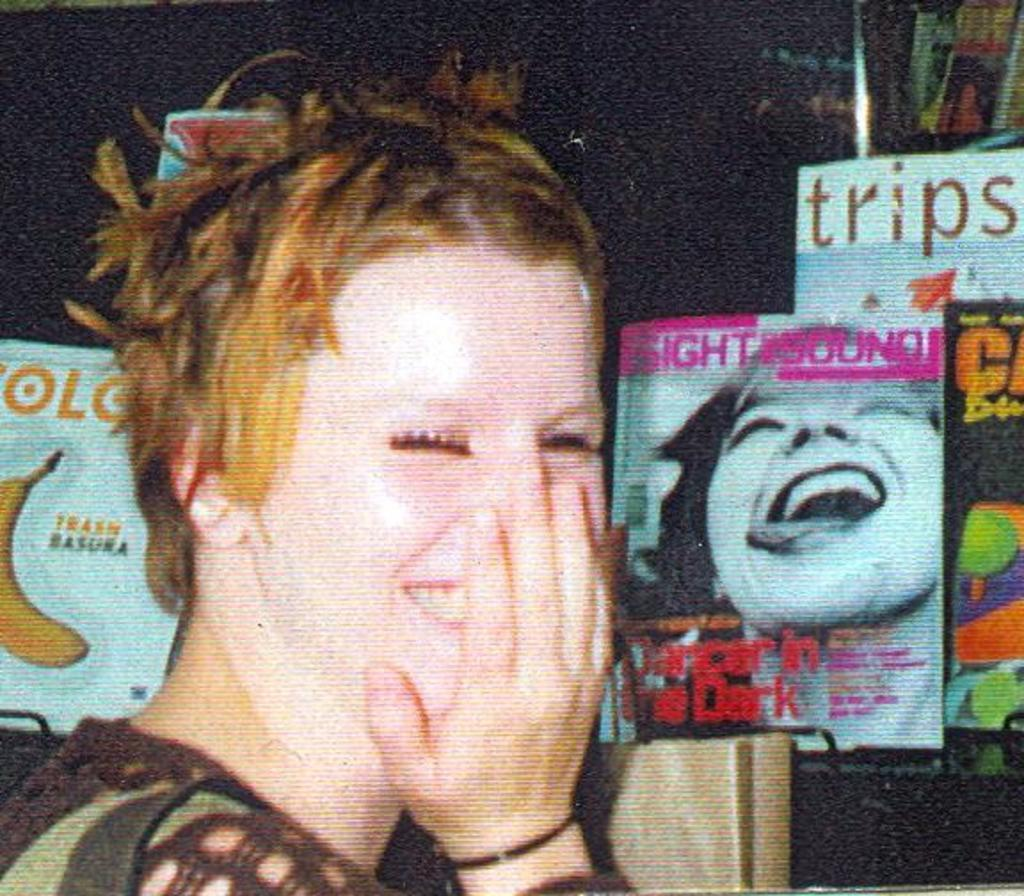What is the primary subject on the left side of the image? There is a woman on the left side of the image. What can be seen in the background of the image? There are books and a handbag in the background of the image. Can you describe the setting of the image? The image might be a screen on a monitor, which suggests it could be a digital representation or a photograph. What type of feather can be seen in the woman's hair in the image? There is no feather visible in the woman's hair in the image. What activities might be taking place at the camp in the image? There is no camp present in the image; it features a woman and some background items. 